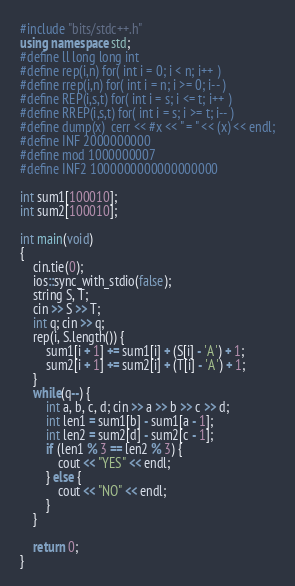<code> <loc_0><loc_0><loc_500><loc_500><_C++_>#include "bits/stdc++.h"
using namespace std;
#define ll long long int
#define rep(i,n) for( int i = 0; i < n; i++ )
#define rrep(i,n) for( int i = n; i >= 0; i-- )
#define REP(i,s,t) for( int i = s; i <= t; i++ )
#define RREP(i,s,t) for( int i = s; i >= t; i-- )
#define dump(x)  cerr << #x << " = " << (x) << endl;
#define INF 2000000000
#define mod 1000000007
#define INF2 1000000000000000000

int sum1[100010];
int sum2[100010];

int main(void)
{
    cin.tie(0);
    ios::sync_with_stdio(false);
    string S, T;
    cin >> S >> T;
    int q; cin >> q;
    rep(i, S.length()) {
        sum1[i + 1] += sum1[i] + (S[i] - 'A') + 1;
        sum2[i + 1] += sum2[i] + (T[i] - 'A') + 1;
    }
    while(q--) {
        int a, b, c, d; cin >> a >> b >> c >> d;
        int len1 = sum1[b] - sum1[a - 1];
        int len2 = sum2[d] - sum2[c - 1];
        if (len1 % 3 == len2 % 3) {
            cout << "YES" << endl;
        } else {
            cout << "NO" << endl;
        }
    }

    return 0;
}
</code> 